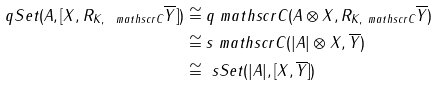Convert formula to latex. <formula><loc_0><loc_0><loc_500><loc_500>\ q S e t ( A , [ X , R _ { K , \ m a t h s c r { C } } \overline { Y } ] ) & \cong q \ m a t h s c r { C } ( A \otimes X , R _ { K , \ m a t h s c r { C } } \overline { Y } ) \\ & \cong s \ m a t h s c r { C } ( | A | \otimes X , \overline { Y } ) \\ & \cong \ s S e t ( | A | , [ X , \overline { Y } ] )</formula> 